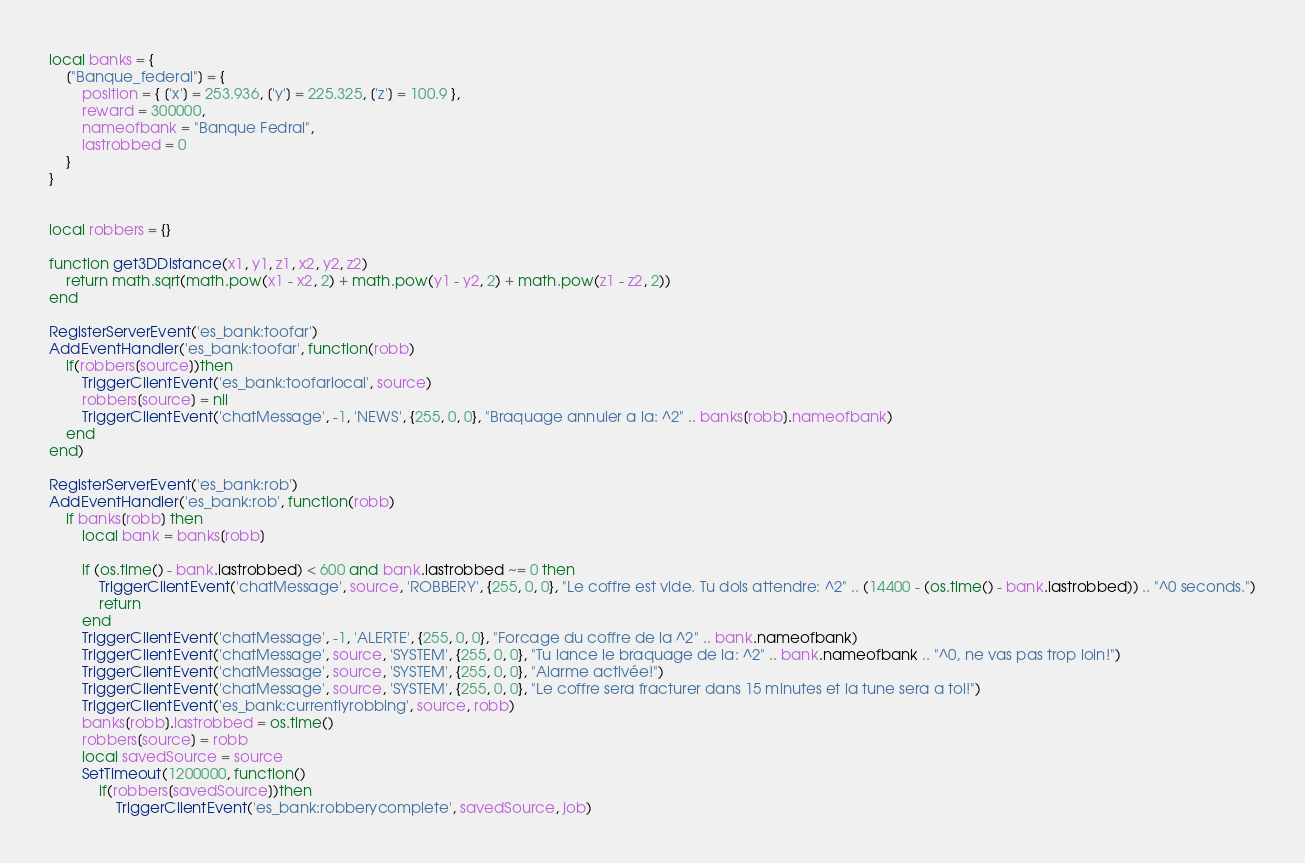<code> <loc_0><loc_0><loc_500><loc_500><_Lua_>local banks = {
	["Banque_federal"] = {
		position = { ['x'] = 253.936, ['y'] = 225.325, ['z'] = 100.9 },
		reward = 300000,
		nameofbank = "Banque Fedral",
		lastrobbed = 0
	}
}


local robbers = {}

function get3DDistance(x1, y1, z1, x2, y2, z2)
	return math.sqrt(math.pow(x1 - x2, 2) + math.pow(y1 - y2, 2) + math.pow(z1 - z2, 2))
end

RegisterServerEvent('es_bank:toofar')
AddEventHandler('es_bank:toofar', function(robb)
	if(robbers[source])then
		TriggerClientEvent('es_bank:toofarlocal', source)
		robbers[source] = nil
		TriggerClientEvent('chatMessage', -1, 'NEWS', {255, 0, 0}, "Braquage annuler a la: ^2" .. banks[robb].nameofbank)
	end
end)

RegisterServerEvent('es_bank:rob')
AddEventHandler('es_bank:rob', function(robb)
	if banks[robb] then
		local bank = banks[robb]

		if (os.time() - bank.lastrobbed) < 600 and bank.lastrobbed ~= 0 then
			TriggerClientEvent('chatMessage', source, 'ROBBERY', {255, 0, 0}, "Le coffre est vide. Tu dois attendre: ^2" .. (14400 - (os.time() - bank.lastrobbed)) .. "^0 seconds.")
			return
		end
		TriggerClientEvent('chatMessage', -1, 'ALERTE', {255, 0, 0}, "Forcage du coffre de la ^2" .. bank.nameofbank)
		TriggerClientEvent('chatMessage', source, 'SYSTEM', {255, 0, 0}, "Tu lance le braquage de la: ^2" .. bank.nameofbank .. "^0, ne vas pas trop loin!")
		TriggerClientEvent('chatMessage', source, 'SYSTEM', {255, 0, 0}, "Alarme activée!")
		TriggerClientEvent('chatMessage', source, 'SYSTEM', {255, 0, 0}, "Le coffre sera fracturer dans 15 minutes et la tune sera a toi!")
		TriggerClientEvent('es_bank:currentlyrobbing', source, robb)
		banks[robb].lastrobbed = os.time()
		robbers[source] = robb
		local savedSource = source
		SetTimeout(1200000, function()
			if(robbers[savedSource])then
				TriggerClientEvent('es_bank:robberycomplete', savedSource, job)</code> 